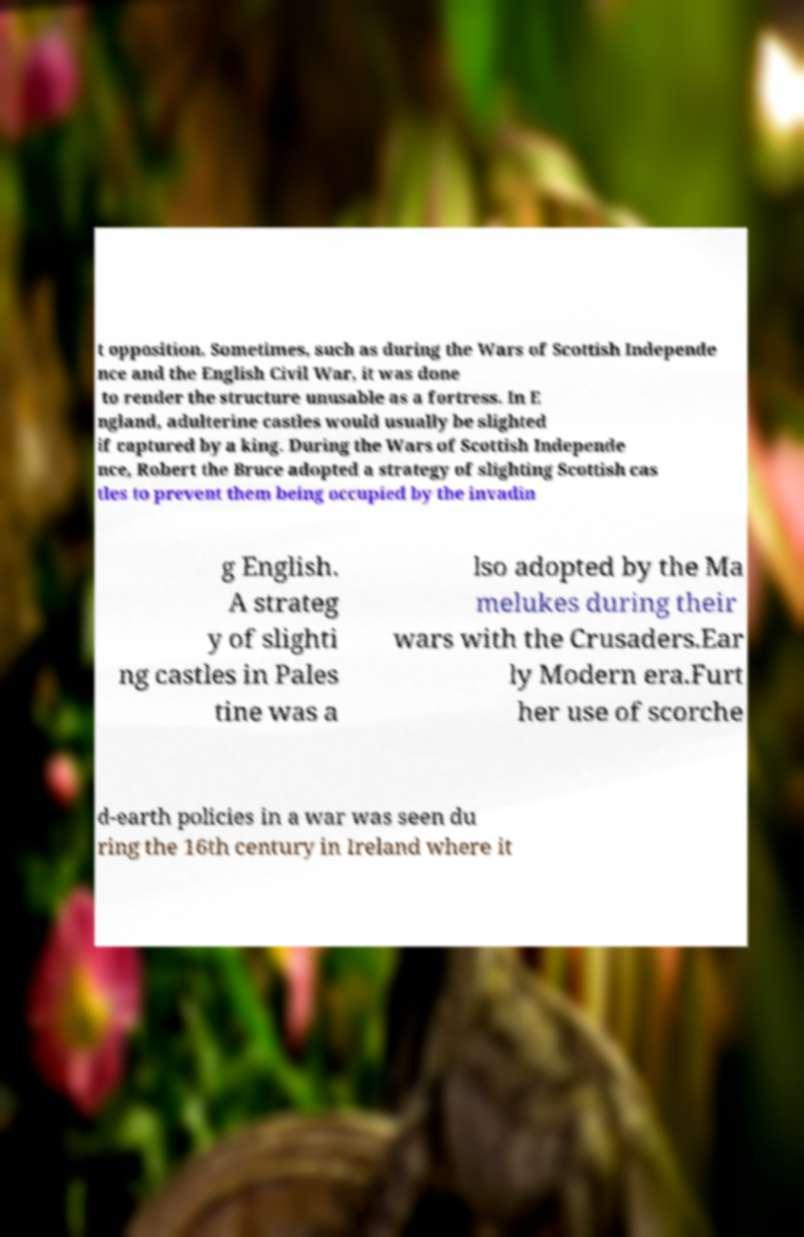I need the written content from this picture converted into text. Can you do that? t opposition. Sometimes, such as during the Wars of Scottish Independe nce and the English Civil War, it was done to render the structure unusable as a fortress. In E ngland, adulterine castles would usually be slighted if captured by a king. During the Wars of Scottish Independe nce, Robert the Bruce adopted a strategy of slighting Scottish cas tles to prevent them being occupied by the invadin g English. A strateg y of slighti ng castles in Pales tine was a lso adopted by the Ma melukes during their wars with the Crusaders.Ear ly Modern era.Furt her use of scorche d-earth policies in a war was seen du ring the 16th century in Ireland where it 